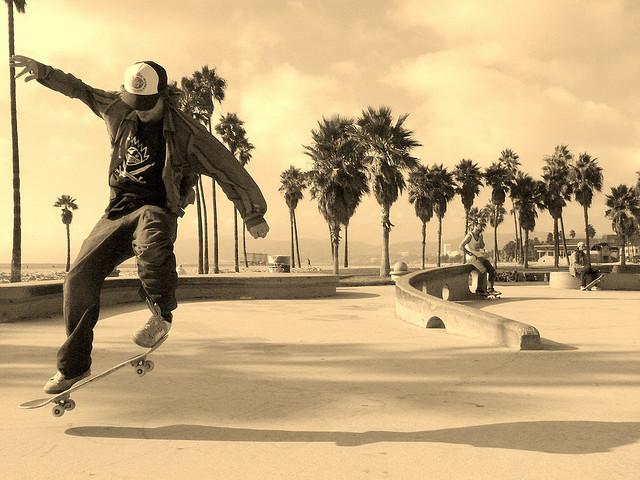What kind of trees are present in the background of this photograph?
Answer briefly. Palm. What surface is he performing on?
Concise answer only. Cement. What kind of trees are in this picture?
Short answer required. Palm. 